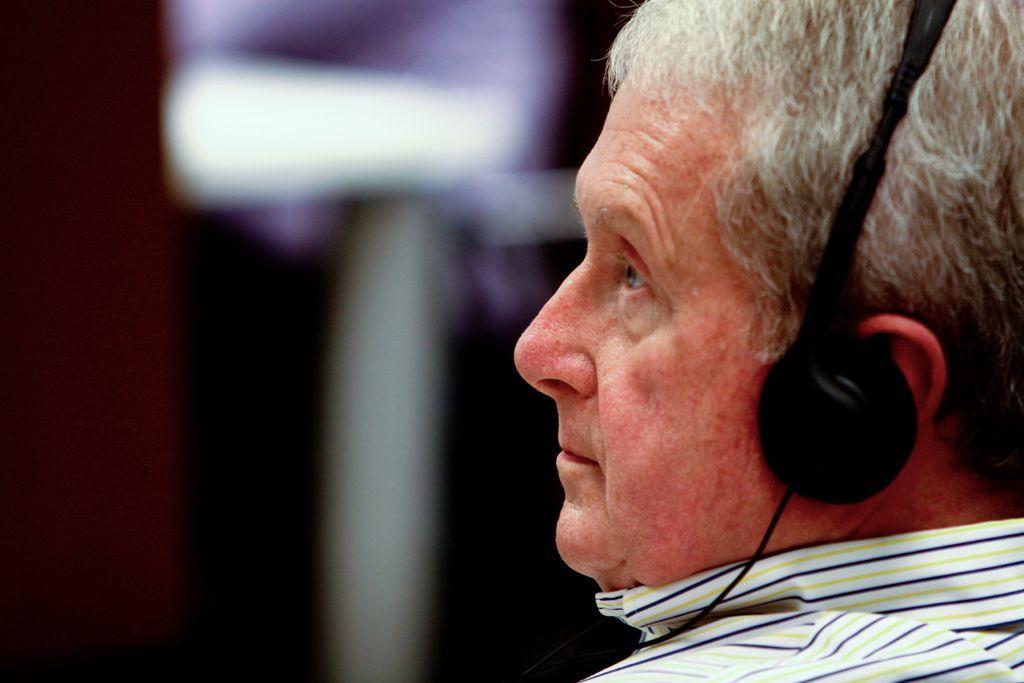Can you describe this image briefly? In the picture there is a man, he is wearing a headset and the background of the man is blur. 